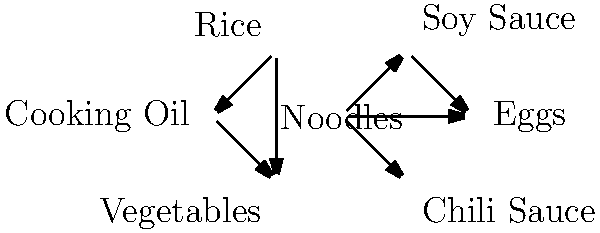Based on the network diagram of product associations for an Indonesian consumer goods company, which product appears to be the most central in terms of connections to other products, and what does this suggest about its importance in market basket analysis? To answer this question, we need to analyze the network diagram and follow these steps:

1. Count the number of connections for each product:
   - Noodles: 3 connections (Soy Sauce, Eggs, Chili Sauce)
   - Soy Sauce: 2 connections (Noodles, Eggs)
   - Eggs: 2 connections (Noodles, Soy Sauce)
   - Chili Sauce: 1 connection (Noodles)
   - Rice: 2 connections (Cooking Oil, Vegetables)
   - Cooking Oil: 2 connections (Rice, Vegetables)
   - Vegetables: 2 connections (Rice, Cooking Oil)

2. Identify the product with the most connections:
   Noodles has the highest number of connections (3).

3. Interpret the significance in market basket analysis:
   - The central position of Noodles suggests it is frequently purchased with other products.
   - This indicates that Noodles is likely a key driver of sales and may be used as a focal point for marketing strategies.
   - The strong associations between Noodles and other products (Soy Sauce, Eggs, Chili Sauce) imply common purchase patterns or cuisine preferences among Indonesian consumers.

4. Consider the business implications:
   - The company could use this information to design promotions or bundle offers centered around Noodles.
   - Product placement in stores could be optimized by placing Noodles near its associated products to encourage cross-selling.
   - New product development could focus on complementary items to Noodles, leveraging its central position in consumer purchasing habits.
Answer: Noodles; central product driving sales and cross-selling opportunities 